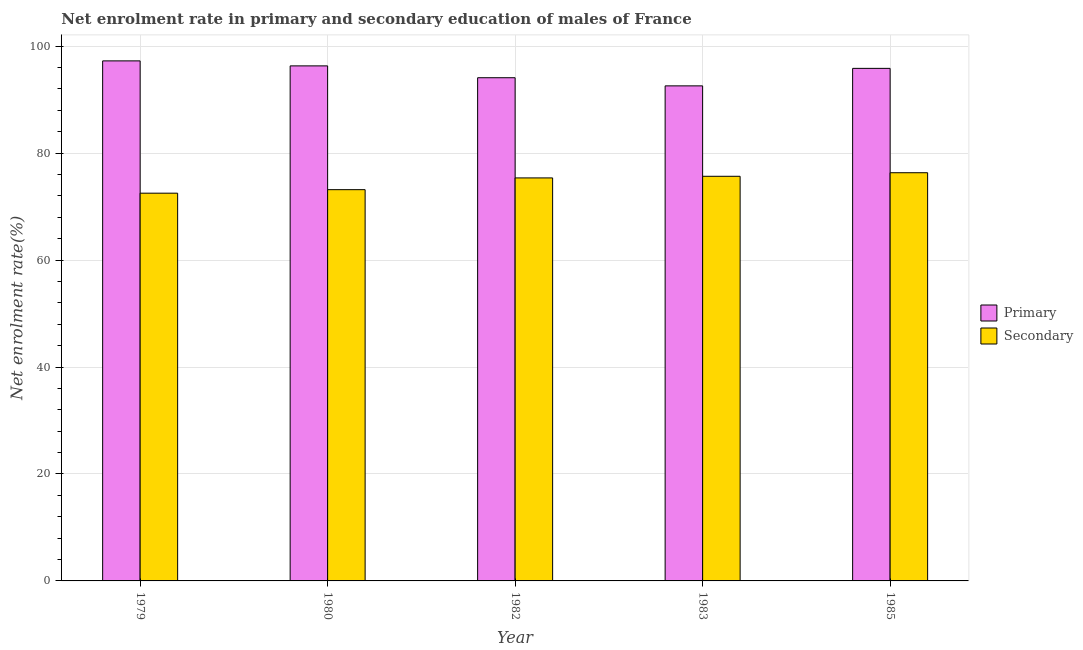How many bars are there on the 5th tick from the right?
Provide a short and direct response. 2. What is the label of the 3rd group of bars from the left?
Your answer should be very brief. 1982. What is the enrollment rate in primary education in 1982?
Give a very brief answer. 94.1. Across all years, what is the maximum enrollment rate in primary education?
Make the answer very short. 97.25. Across all years, what is the minimum enrollment rate in secondary education?
Offer a very short reply. 72.51. In which year was the enrollment rate in secondary education maximum?
Your answer should be compact. 1985. In which year was the enrollment rate in secondary education minimum?
Offer a very short reply. 1979. What is the total enrollment rate in secondary education in the graph?
Your answer should be very brief. 373.05. What is the difference between the enrollment rate in primary education in 1980 and that in 1982?
Provide a succinct answer. 2.21. What is the difference between the enrollment rate in primary education in 1982 and the enrollment rate in secondary education in 1983?
Ensure brevity in your answer.  1.52. What is the average enrollment rate in primary education per year?
Ensure brevity in your answer.  95.22. In the year 1982, what is the difference between the enrollment rate in secondary education and enrollment rate in primary education?
Give a very brief answer. 0. What is the ratio of the enrollment rate in primary education in 1979 to that in 1983?
Your answer should be compact. 1.05. Is the enrollment rate in primary education in 1980 less than that in 1985?
Offer a very short reply. No. Is the difference between the enrollment rate in primary education in 1979 and 1980 greater than the difference between the enrollment rate in secondary education in 1979 and 1980?
Offer a terse response. No. What is the difference between the highest and the second highest enrollment rate in secondary education?
Give a very brief answer. 0.67. What is the difference between the highest and the lowest enrollment rate in secondary education?
Provide a succinct answer. 3.82. In how many years, is the enrollment rate in primary education greater than the average enrollment rate in primary education taken over all years?
Your response must be concise. 3. What does the 1st bar from the left in 1979 represents?
Give a very brief answer. Primary. What does the 2nd bar from the right in 1979 represents?
Ensure brevity in your answer.  Primary. How many bars are there?
Give a very brief answer. 10. What is the difference between two consecutive major ticks on the Y-axis?
Your response must be concise. 20. Does the graph contain grids?
Your answer should be very brief. Yes. How many legend labels are there?
Give a very brief answer. 2. What is the title of the graph?
Your answer should be very brief. Net enrolment rate in primary and secondary education of males of France. What is the label or title of the Y-axis?
Provide a succinct answer. Net enrolment rate(%). What is the Net enrolment rate(%) of Primary in 1979?
Keep it short and to the point. 97.25. What is the Net enrolment rate(%) of Secondary in 1979?
Ensure brevity in your answer.  72.51. What is the Net enrolment rate(%) of Primary in 1980?
Keep it short and to the point. 96.32. What is the Net enrolment rate(%) in Secondary in 1980?
Your response must be concise. 73.17. What is the Net enrolment rate(%) of Primary in 1982?
Ensure brevity in your answer.  94.1. What is the Net enrolment rate(%) in Secondary in 1982?
Provide a short and direct response. 75.36. What is the Net enrolment rate(%) in Primary in 1983?
Your answer should be compact. 92.58. What is the Net enrolment rate(%) of Secondary in 1983?
Offer a terse response. 75.67. What is the Net enrolment rate(%) in Primary in 1985?
Provide a short and direct response. 95.85. What is the Net enrolment rate(%) in Secondary in 1985?
Offer a very short reply. 76.33. Across all years, what is the maximum Net enrolment rate(%) of Primary?
Offer a terse response. 97.25. Across all years, what is the maximum Net enrolment rate(%) in Secondary?
Offer a very short reply. 76.33. Across all years, what is the minimum Net enrolment rate(%) of Primary?
Give a very brief answer. 92.58. Across all years, what is the minimum Net enrolment rate(%) of Secondary?
Your answer should be very brief. 72.51. What is the total Net enrolment rate(%) of Primary in the graph?
Provide a short and direct response. 476.1. What is the total Net enrolment rate(%) of Secondary in the graph?
Your answer should be very brief. 373.05. What is the difference between the Net enrolment rate(%) of Primary in 1979 and that in 1980?
Your answer should be very brief. 0.94. What is the difference between the Net enrolment rate(%) in Secondary in 1979 and that in 1980?
Ensure brevity in your answer.  -0.66. What is the difference between the Net enrolment rate(%) of Primary in 1979 and that in 1982?
Provide a short and direct response. 3.15. What is the difference between the Net enrolment rate(%) in Secondary in 1979 and that in 1982?
Provide a succinct answer. -2.85. What is the difference between the Net enrolment rate(%) in Primary in 1979 and that in 1983?
Offer a very short reply. 4.67. What is the difference between the Net enrolment rate(%) of Secondary in 1979 and that in 1983?
Provide a short and direct response. -3.16. What is the difference between the Net enrolment rate(%) of Primary in 1979 and that in 1985?
Provide a succinct answer. 1.4. What is the difference between the Net enrolment rate(%) in Secondary in 1979 and that in 1985?
Provide a short and direct response. -3.82. What is the difference between the Net enrolment rate(%) in Primary in 1980 and that in 1982?
Offer a very short reply. 2.21. What is the difference between the Net enrolment rate(%) in Secondary in 1980 and that in 1982?
Offer a terse response. -2.19. What is the difference between the Net enrolment rate(%) of Primary in 1980 and that in 1983?
Offer a very short reply. 3.74. What is the difference between the Net enrolment rate(%) of Secondary in 1980 and that in 1983?
Make the answer very short. -2.5. What is the difference between the Net enrolment rate(%) in Primary in 1980 and that in 1985?
Offer a very short reply. 0.46. What is the difference between the Net enrolment rate(%) of Secondary in 1980 and that in 1985?
Offer a very short reply. -3.17. What is the difference between the Net enrolment rate(%) in Primary in 1982 and that in 1983?
Give a very brief answer. 1.52. What is the difference between the Net enrolment rate(%) in Secondary in 1982 and that in 1983?
Provide a succinct answer. -0.3. What is the difference between the Net enrolment rate(%) in Primary in 1982 and that in 1985?
Ensure brevity in your answer.  -1.75. What is the difference between the Net enrolment rate(%) in Secondary in 1982 and that in 1985?
Provide a short and direct response. -0.97. What is the difference between the Net enrolment rate(%) in Primary in 1983 and that in 1985?
Ensure brevity in your answer.  -3.27. What is the difference between the Net enrolment rate(%) in Secondary in 1983 and that in 1985?
Offer a very short reply. -0.67. What is the difference between the Net enrolment rate(%) of Primary in 1979 and the Net enrolment rate(%) of Secondary in 1980?
Provide a succinct answer. 24.08. What is the difference between the Net enrolment rate(%) in Primary in 1979 and the Net enrolment rate(%) in Secondary in 1982?
Your response must be concise. 21.89. What is the difference between the Net enrolment rate(%) of Primary in 1979 and the Net enrolment rate(%) of Secondary in 1983?
Provide a short and direct response. 21.58. What is the difference between the Net enrolment rate(%) of Primary in 1979 and the Net enrolment rate(%) of Secondary in 1985?
Give a very brief answer. 20.92. What is the difference between the Net enrolment rate(%) in Primary in 1980 and the Net enrolment rate(%) in Secondary in 1982?
Offer a terse response. 20.95. What is the difference between the Net enrolment rate(%) in Primary in 1980 and the Net enrolment rate(%) in Secondary in 1983?
Provide a succinct answer. 20.65. What is the difference between the Net enrolment rate(%) in Primary in 1980 and the Net enrolment rate(%) in Secondary in 1985?
Keep it short and to the point. 19.98. What is the difference between the Net enrolment rate(%) in Primary in 1982 and the Net enrolment rate(%) in Secondary in 1983?
Make the answer very short. 18.43. What is the difference between the Net enrolment rate(%) of Primary in 1982 and the Net enrolment rate(%) of Secondary in 1985?
Give a very brief answer. 17.77. What is the difference between the Net enrolment rate(%) in Primary in 1983 and the Net enrolment rate(%) in Secondary in 1985?
Provide a succinct answer. 16.24. What is the average Net enrolment rate(%) of Primary per year?
Offer a very short reply. 95.22. What is the average Net enrolment rate(%) of Secondary per year?
Keep it short and to the point. 74.61. In the year 1979, what is the difference between the Net enrolment rate(%) in Primary and Net enrolment rate(%) in Secondary?
Ensure brevity in your answer.  24.74. In the year 1980, what is the difference between the Net enrolment rate(%) of Primary and Net enrolment rate(%) of Secondary?
Provide a short and direct response. 23.15. In the year 1982, what is the difference between the Net enrolment rate(%) in Primary and Net enrolment rate(%) in Secondary?
Your answer should be compact. 18.74. In the year 1983, what is the difference between the Net enrolment rate(%) of Primary and Net enrolment rate(%) of Secondary?
Offer a very short reply. 16.91. In the year 1985, what is the difference between the Net enrolment rate(%) in Primary and Net enrolment rate(%) in Secondary?
Your answer should be compact. 19.52. What is the ratio of the Net enrolment rate(%) of Primary in 1979 to that in 1980?
Your answer should be very brief. 1.01. What is the ratio of the Net enrolment rate(%) in Primary in 1979 to that in 1982?
Offer a terse response. 1.03. What is the ratio of the Net enrolment rate(%) in Secondary in 1979 to that in 1982?
Make the answer very short. 0.96. What is the ratio of the Net enrolment rate(%) of Primary in 1979 to that in 1983?
Provide a succinct answer. 1.05. What is the ratio of the Net enrolment rate(%) in Secondary in 1979 to that in 1983?
Provide a succinct answer. 0.96. What is the ratio of the Net enrolment rate(%) in Primary in 1979 to that in 1985?
Provide a short and direct response. 1.01. What is the ratio of the Net enrolment rate(%) of Secondary in 1979 to that in 1985?
Provide a short and direct response. 0.95. What is the ratio of the Net enrolment rate(%) of Primary in 1980 to that in 1982?
Give a very brief answer. 1.02. What is the ratio of the Net enrolment rate(%) in Secondary in 1980 to that in 1982?
Ensure brevity in your answer.  0.97. What is the ratio of the Net enrolment rate(%) of Primary in 1980 to that in 1983?
Your answer should be compact. 1.04. What is the ratio of the Net enrolment rate(%) in Primary in 1980 to that in 1985?
Offer a very short reply. 1. What is the ratio of the Net enrolment rate(%) of Secondary in 1980 to that in 1985?
Your answer should be very brief. 0.96. What is the ratio of the Net enrolment rate(%) of Primary in 1982 to that in 1983?
Offer a very short reply. 1.02. What is the ratio of the Net enrolment rate(%) in Primary in 1982 to that in 1985?
Offer a very short reply. 0.98. What is the ratio of the Net enrolment rate(%) in Secondary in 1982 to that in 1985?
Keep it short and to the point. 0.99. What is the ratio of the Net enrolment rate(%) in Primary in 1983 to that in 1985?
Keep it short and to the point. 0.97. What is the ratio of the Net enrolment rate(%) in Secondary in 1983 to that in 1985?
Your response must be concise. 0.99. What is the difference between the highest and the second highest Net enrolment rate(%) in Primary?
Give a very brief answer. 0.94. What is the difference between the highest and the second highest Net enrolment rate(%) in Secondary?
Make the answer very short. 0.67. What is the difference between the highest and the lowest Net enrolment rate(%) of Primary?
Offer a very short reply. 4.67. What is the difference between the highest and the lowest Net enrolment rate(%) in Secondary?
Your response must be concise. 3.82. 